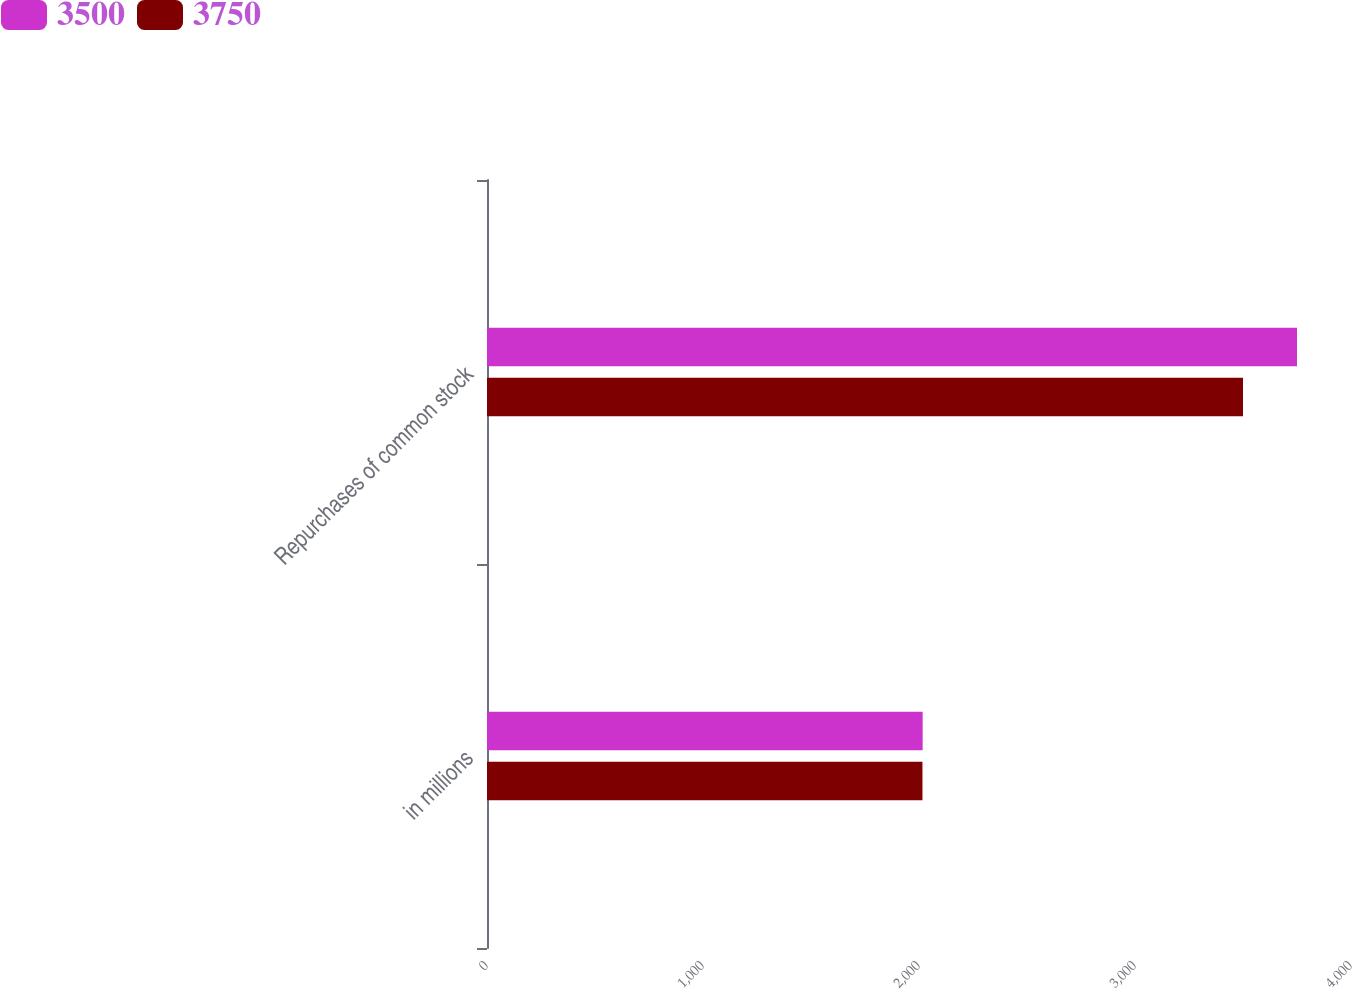Convert chart to OTSL. <chart><loc_0><loc_0><loc_500><loc_500><stacked_bar_chart><ecel><fcel>in millions<fcel>Repurchases of common stock<nl><fcel>3500<fcel>2017<fcel>3750<nl><fcel>3750<fcel>2016<fcel>3500<nl></chart> 